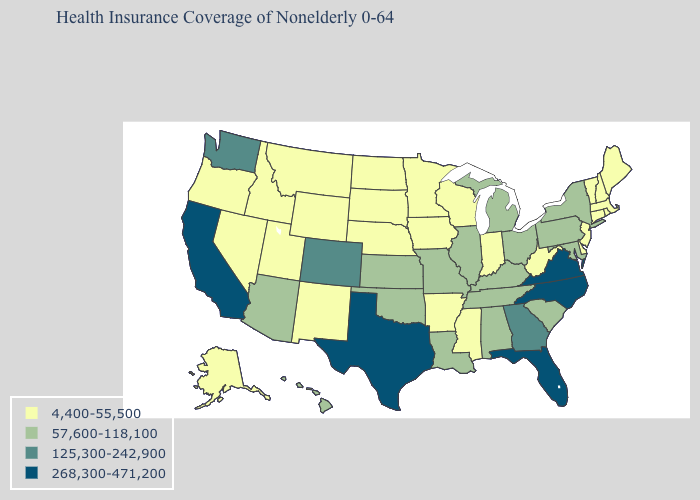Name the states that have a value in the range 125,300-242,900?
Be succinct. Colorado, Georgia, Washington. Among the states that border South Carolina , does Georgia have the lowest value?
Write a very short answer. Yes. Which states hav the highest value in the MidWest?
Short answer required. Illinois, Kansas, Michigan, Missouri, Ohio. Does Alaska have the lowest value in the USA?
Keep it brief. Yes. Name the states that have a value in the range 57,600-118,100?
Short answer required. Alabama, Arizona, Hawaii, Illinois, Kansas, Kentucky, Louisiana, Maryland, Michigan, Missouri, New York, Ohio, Oklahoma, Pennsylvania, South Carolina, Tennessee. What is the value of Delaware?
Give a very brief answer. 4,400-55,500. What is the value of California?
Answer briefly. 268,300-471,200. Does South Dakota have the same value as Pennsylvania?
Concise answer only. No. Name the states that have a value in the range 57,600-118,100?
Concise answer only. Alabama, Arizona, Hawaii, Illinois, Kansas, Kentucky, Louisiana, Maryland, Michigan, Missouri, New York, Ohio, Oklahoma, Pennsylvania, South Carolina, Tennessee. Among the states that border Oklahoma , does Missouri have the lowest value?
Quick response, please. No. What is the value of New Jersey?
Write a very short answer. 4,400-55,500. Among the states that border New Hampshire , which have the lowest value?
Short answer required. Maine, Massachusetts, Vermont. What is the highest value in the USA?
Concise answer only. 268,300-471,200. Which states have the lowest value in the Northeast?
Answer briefly. Connecticut, Maine, Massachusetts, New Hampshire, New Jersey, Rhode Island, Vermont. 